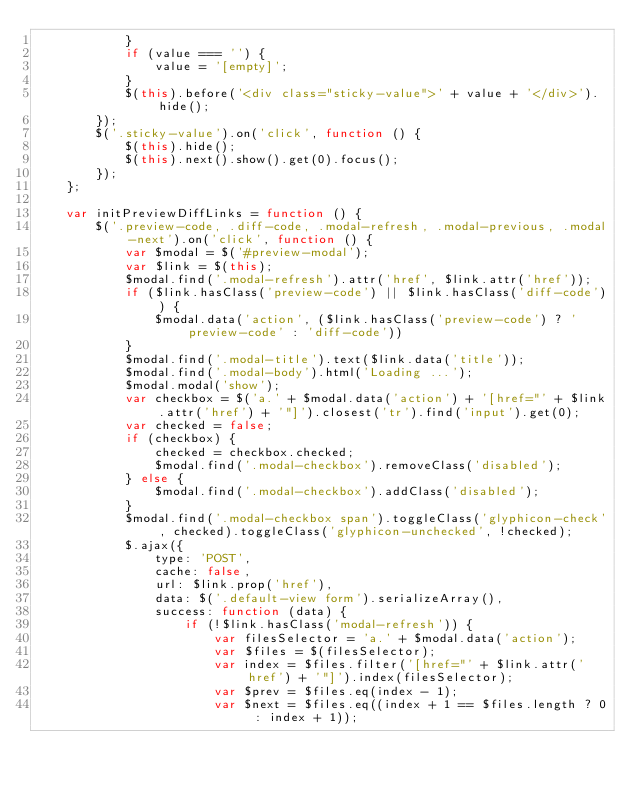Convert code to text. <code><loc_0><loc_0><loc_500><loc_500><_JavaScript_>            }
            if (value === '') {
                value = '[empty]';
            }
            $(this).before('<div class="sticky-value">' + value + '</div>').hide();
        });
        $('.sticky-value').on('click', function () {
            $(this).hide();
            $(this).next().show().get(0).focus();
        });
    };

    var initPreviewDiffLinks = function () {
        $('.preview-code, .diff-code, .modal-refresh, .modal-previous, .modal-next').on('click', function () {
            var $modal = $('#preview-modal');
            var $link = $(this);
            $modal.find('.modal-refresh').attr('href', $link.attr('href'));
            if ($link.hasClass('preview-code') || $link.hasClass('diff-code')) {
                $modal.data('action', ($link.hasClass('preview-code') ? 'preview-code' : 'diff-code'))
            }
            $modal.find('.modal-title').text($link.data('title'));
            $modal.find('.modal-body').html('Loading ...');
            $modal.modal('show');
            var checkbox = $('a.' + $modal.data('action') + '[href="' + $link.attr('href') + '"]').closest('tr').find('input').get(0);
            var checked = false;
            if (checkbox) {
                checked = checkbox.checked;
                $modal.find('.modal-checkbox').removeClass('disabled');
            } else {
                $modal.find('.modal-checkbox').addClass('disabled');
            }
            $modal.find('.modal-checkbox span').toggleClass('glyphicon-check', checked).toggleClass('glyphicon-unchecked', !checked);
            $.ajax({
                type: 'POST',
                cache: false,
                url: $link.prop('href'),
                data: $('.default-view form').serializeArray(),
                success: function (data) {
                    if (!$link.hasClass('modal-refresh')) {
                        var filesSelector = 'a.' + $modal.data('action');
                        var $files = $(filesSelector);
                        var index = $files.filter('[href="' + $link.attr('href') + '"]').index(filesSelector);
                        var $prev = $files.eq(index - 1);
                        var $next = $files.eq((index + 1 == $files.length ? 0 : index + 1));</code> 